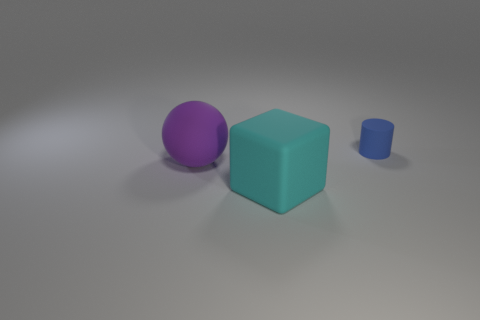Does the blue rubber cylinder have the same size as the thing that is in front of the large purple object?
Provide a succinct answer. No. How many matte blocks are in front of the large matte thing left of the large thing on the right side of the large purple sphere?
Your answer should be compact. 1. There is a small cylinder; how many cyan matte things are behind it?
Keep it short and to the point. 0. The large object in front of the large object that is behind the big cyan object is what color?
Make the answer very short. Cyan. Are there the same number of cyan blocks that are left of the ball and blue matte things?
Keep it short and to the point. No. The object on the left side of the large rubber cube is what color?
Offer a very short reply. Purple. What is the size of the object that is to the left of the big object that is to the right of the big purple ball?
Your answer should be compact. Large. Are there the same number of big purple rubber balls behind the large purple ball and blue cylinders that are behind the large cyan object?
Your answer should be very brief. No. Is there anything else that is the same size as the blue rubber thing?
Your response must be concise. No. The other small object that is the same material as the purple object is what color?
Your answer should be compact. Blue. 